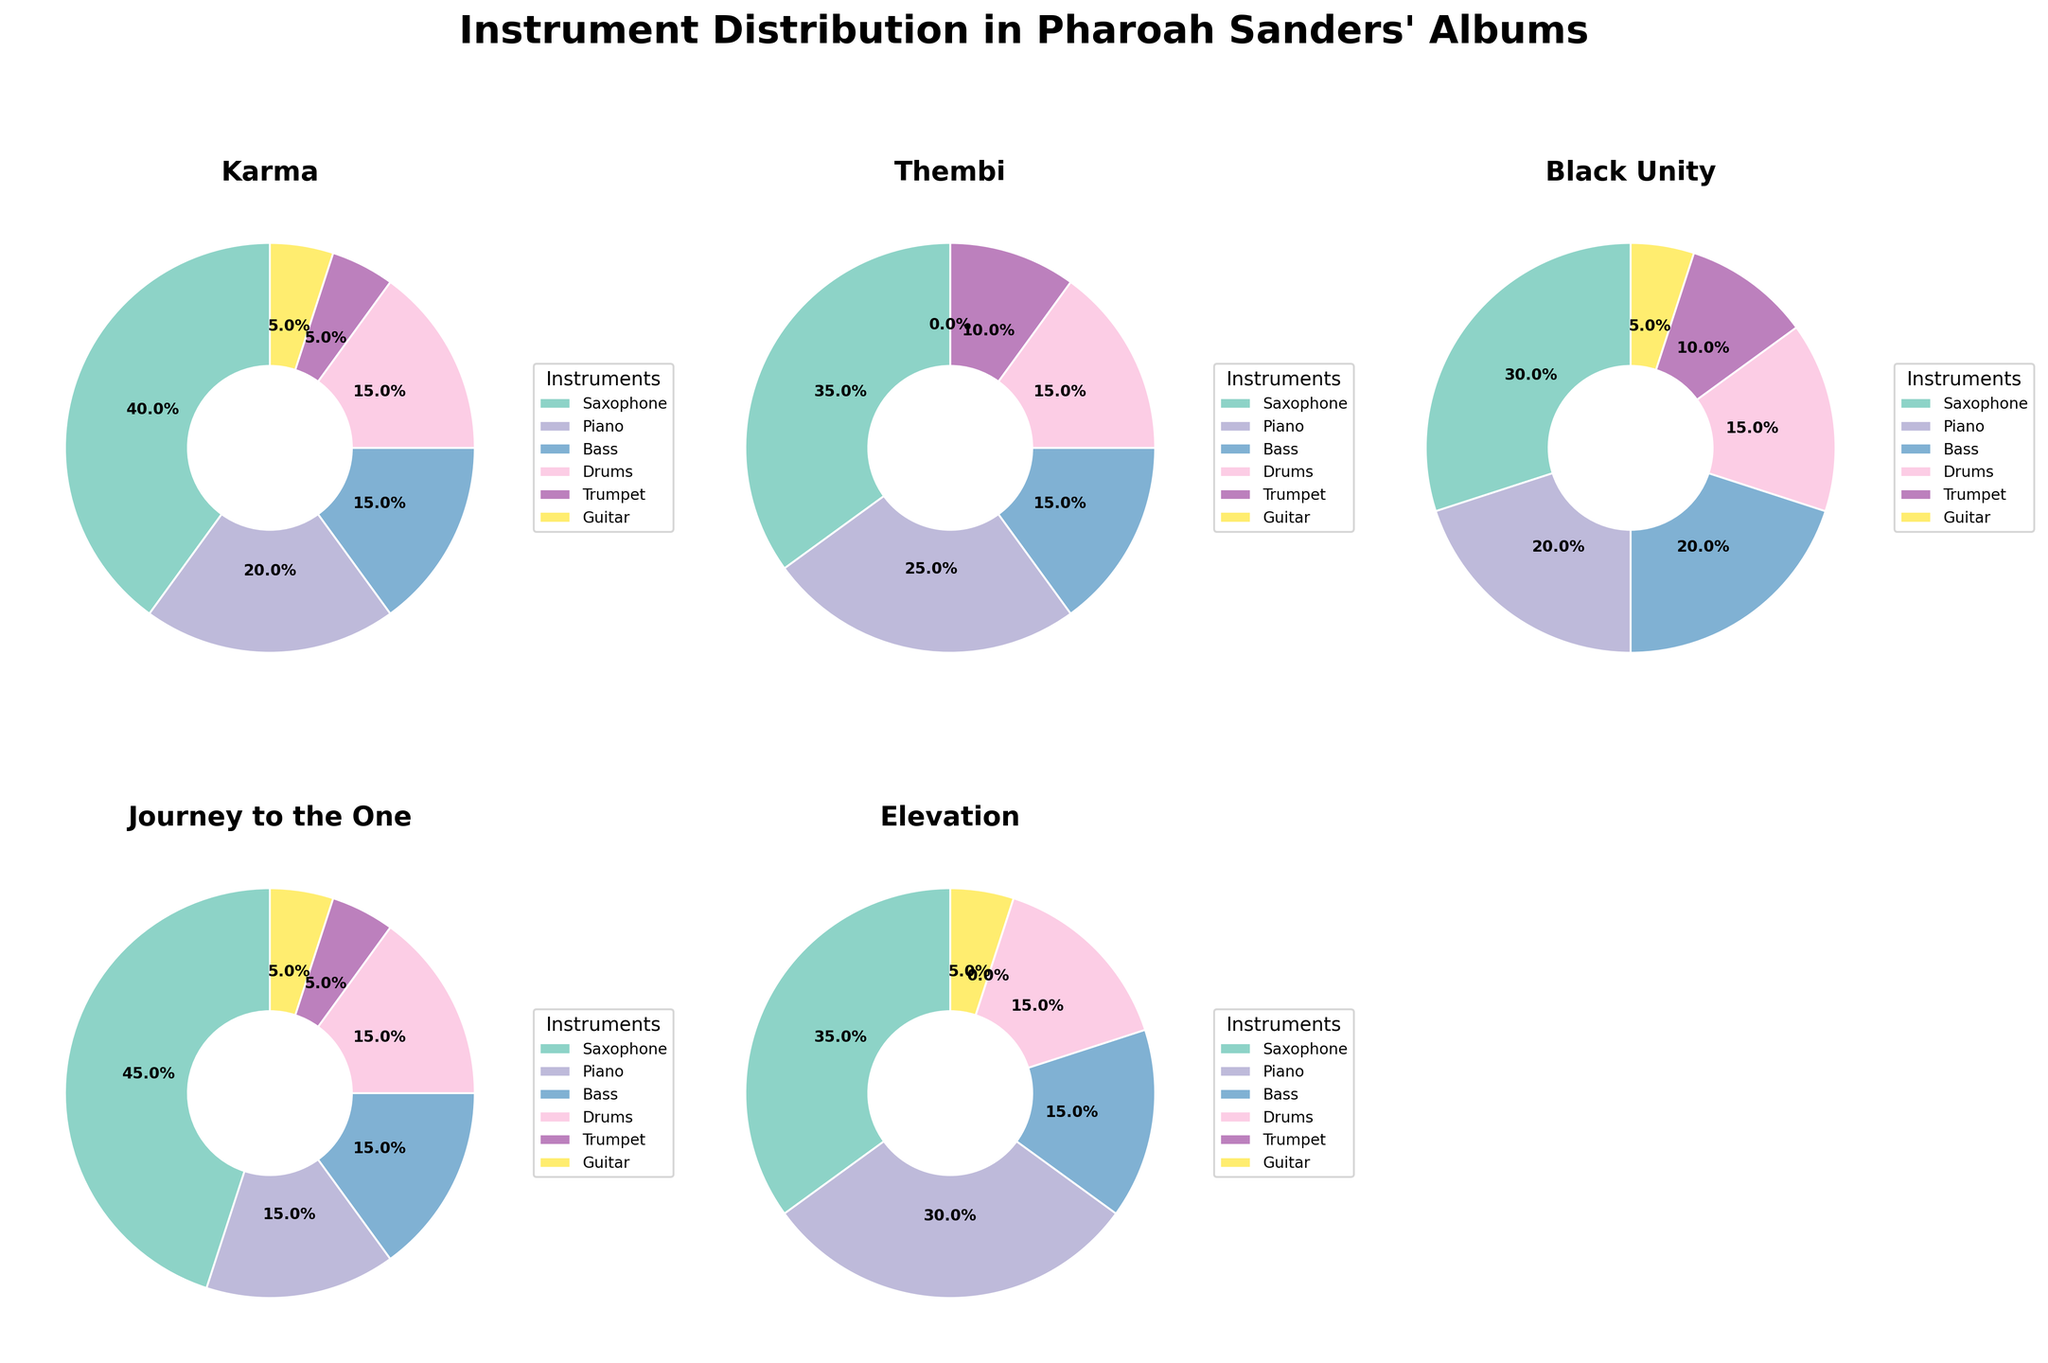what is the title of the figure? The title of the figure is written at the top of the figure. It says "Instrument Distribution in Pharoah Sanders' Albums".
Answer: Instrument Distribution in Pharoah Sanders' Albums Which instrument has the highest percentage in the album “Journey to the One”? The slices of the pie chart for the album “Journey to the One” indicate the percentage of different instruments used. The largest slice represents the Saxophone at 45%.
Answer: Saxophone Is there any album where Guitar is not used? By observing the pie charts, the "Thembi" album's slice for Guitar is absent, indicating 0%.
Answer: Thembi What is the combined percentage of Saxophone and Trumpet in the album "Karma"? In the "Karma" album, Saxophone is 40% and Trumpet is 5%. Adding them together: 40 + 5 = 45%.
Answer: 45% Which album has the least variation in the percentage of instruments used? By comparing the pie charts, the “Black Unity” album displays relatively balanced slices with percentages: 30, 20, 20, 15, 10, 5. The differences between these values are smaller compared to other albums.
Answer: Black Unity How does the percentage of Piano in “Elevation” compare to that in "Journey to the One"? The "Elevation" album shows a Piano percentage of 30%, while "Journey to the One" shows a Piano percentage of 15%. Thus, the Piano percentage in "Elevation" is higher.
Answer: Higher Which album has the highest percentage of Drums? By looking at the pie charts, all albums have the same percentage of Drums, which is 15%.
Answer: All albums What is the average percentage of Bass used across all albums? For each album, the Bass percentages are 15, 15, 20, 15, and 15. Summing these percentages: 15 + 15 + 20 + 15 + 15 = 80. The average is calculated by dividing the sum by the number of albums: 80 / 5 = 16%.
Answer: 16% Which album features the largest wedge for the Trumpet? The charts show the percentage of Trumpet usage in each album. Thembi and Black Unity both show a 10% usage of Trumpet. They both have the largest wedge for the Trumpet among all the albums.
Answer: Thembi and Black Unity 